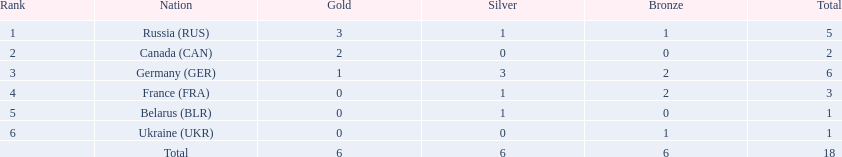Which countries competed in the 1995 biathlon? Russia (RUS), Canada (CAN), Germany (GER), France (FRA), Belarus (BLR), Ukraine (UKR). How many medals in total did they win? 5, 2, 6, 3, 1, 1. And which country had the most? Germany (GER). 